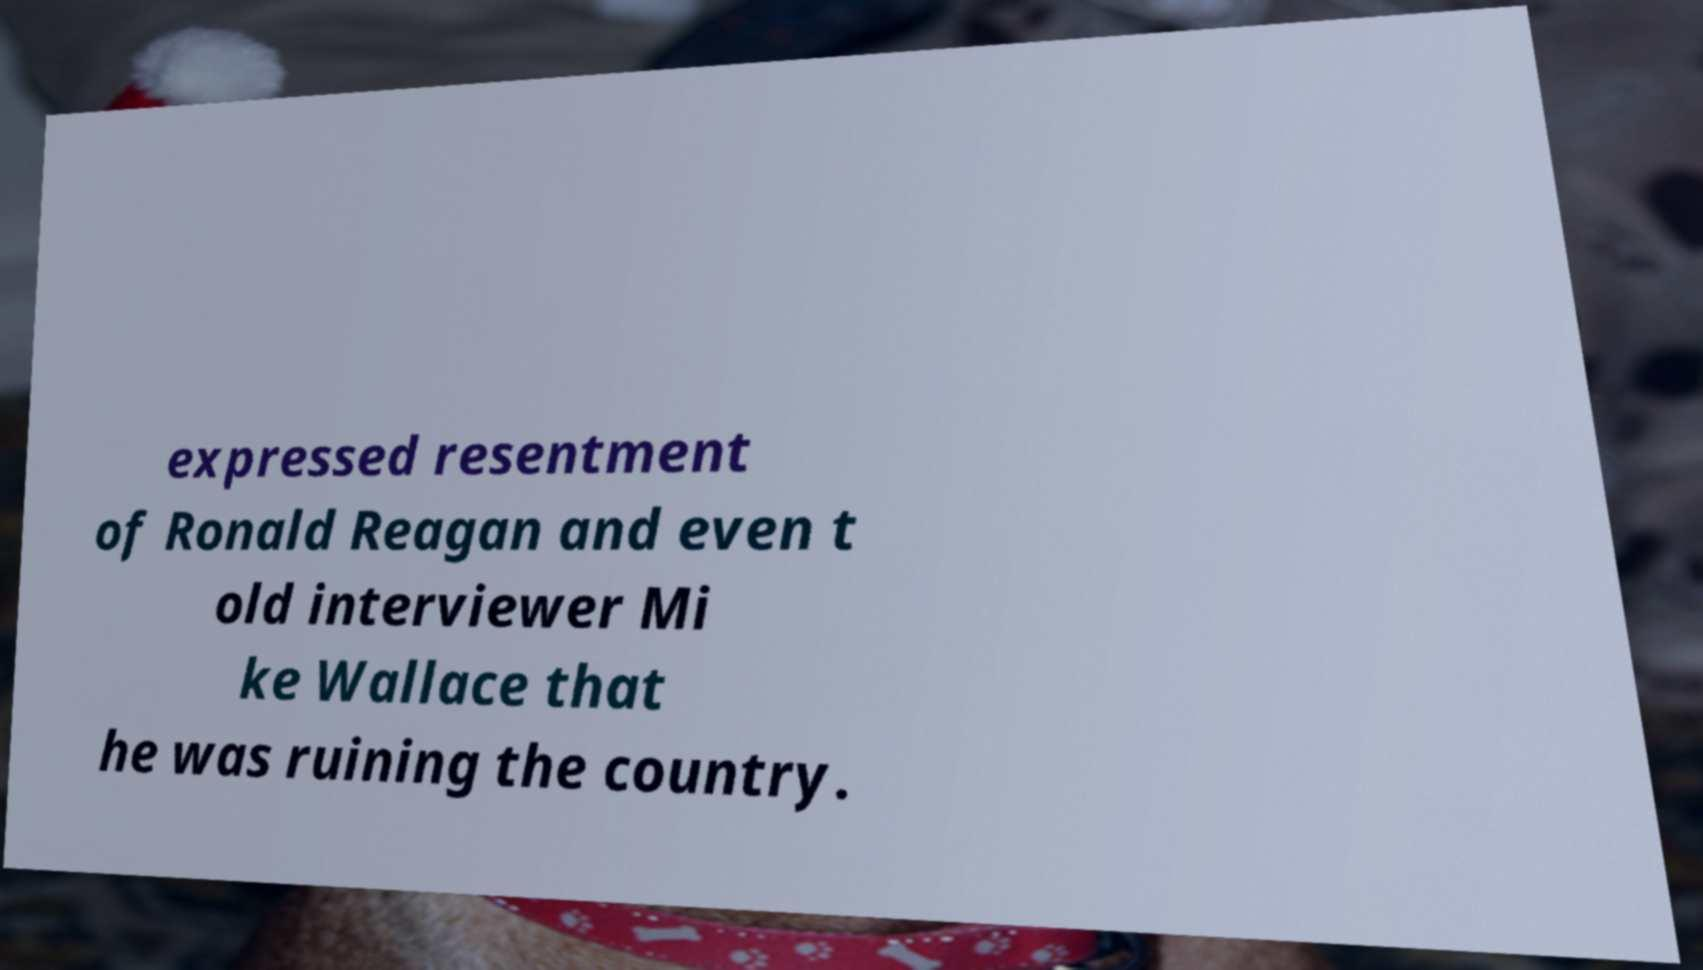I need the written content from this picture converted into text. Can you do that? expressed resentment of Ronald Reagan and even t old interviewer Mi ke Wallace that he was ruining the country. 